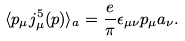Convert formula to latex. <formula><loc_0><loc_0><loc_500><loc_500>\langle p _ { \mu } j ^ { 5 } _ { \mu } ( p ) \rangle _ { a } = \frac { e } { \pi } \epsilon _ { \mu \nu } p _ { \mu } a _ { \nu } .</formula> 